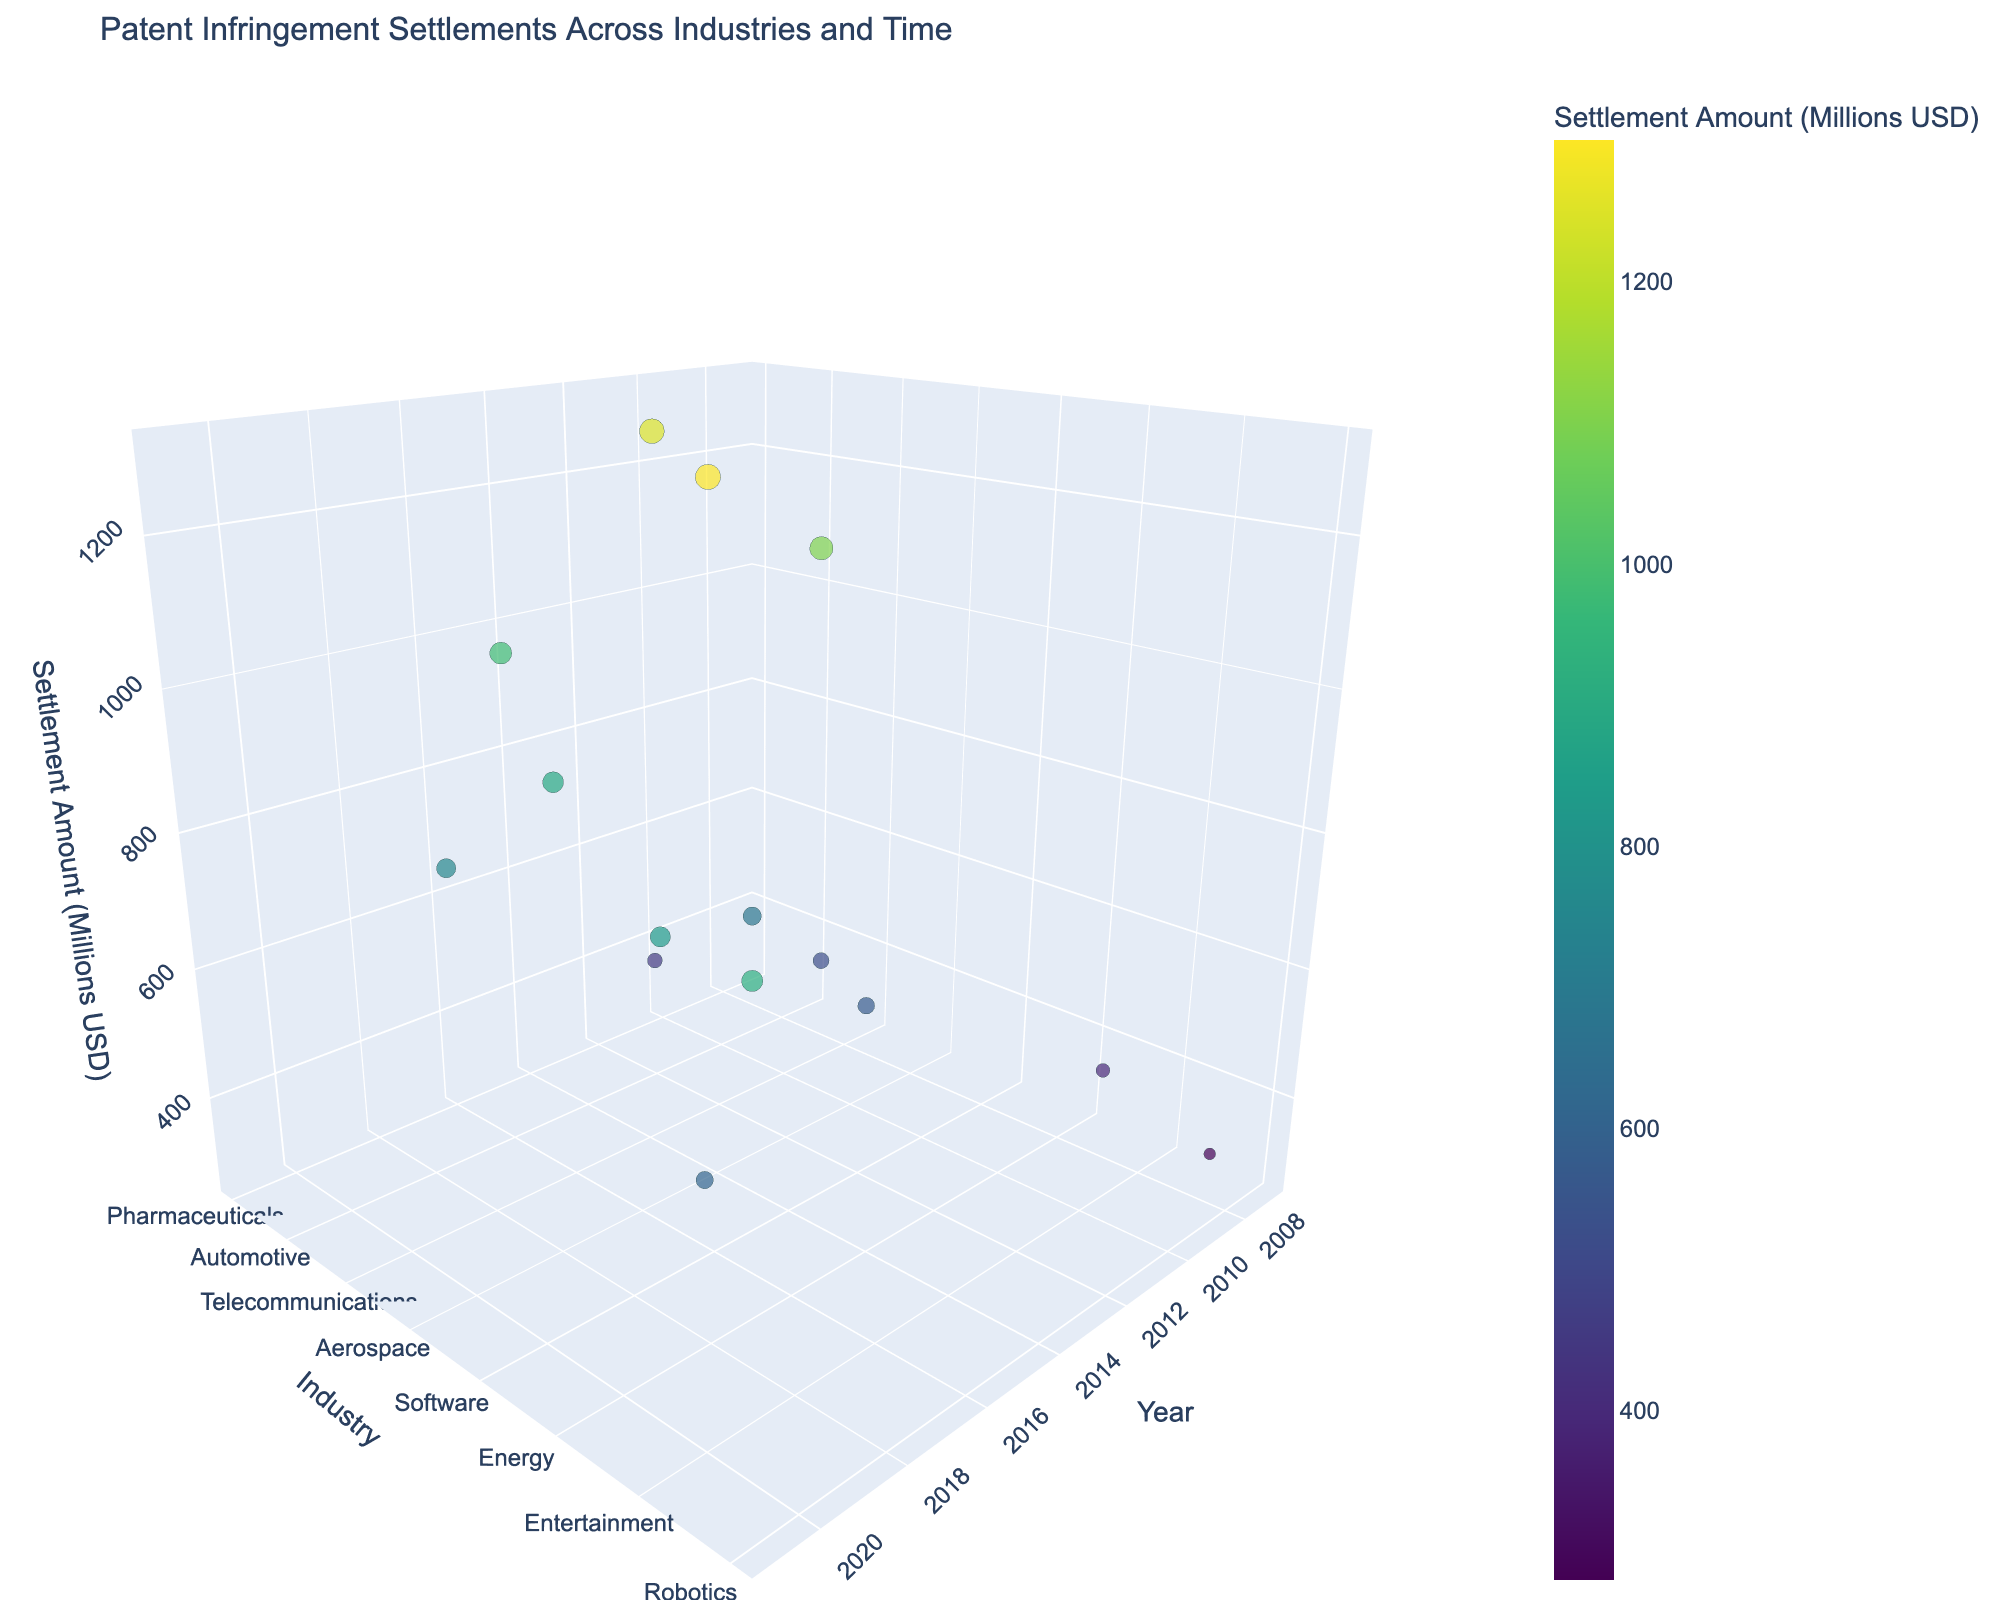What's the title of the figure? The title of the figure is usually found at the top of the chart, indicating the subject of the plot. Here, it shows the main focus of the data presented.
Answer: Patent Infringement Settlements Across Industries and Time What are the axes labels? The labels on the axes give information about what each axis represents. We have three axes to consider in this 3D plot: the x-axis, y-axis, and z-axis. Each label corresponds to the respective data being plotted.
Answer: Year, Industry, Settlement Amount (Millions USD) Which industry had the highest settlement amount, and what year was it settled? To find this answer, look at the maximum height (z-axis) on the scatter plot, and check the corresponding industry label (y-axis) and year (x-axis).
Answer: Software, 2016 How many data points are there in the figure? By counting the number of markers (data points) on the plot, we can determine the total number of unique observations. Each marker represents one patent settlement case.
Answer: 15 What's the difference in settlement amounts between the Pharmaceuticals industry in 2010 and the Technology industry in 2015? Locate both data points on the z-axis and calculate the difference. Pharmaceuticals 2010 has a settlement of 1250 million USD, and Technology 2015 has 980 million USD. The difference is 1250 - 980.
Answer: 270 million USD What is the median settlement amount across all industries? To find the median, list all the settlement amounts, sort them in ascending order, and find the middle value. If there is an even number of points, take the average of the two middle values.
Answer: 750 million USD Which industry had the earliest recorded settlement? Look along the x-axis for the earliest year and identify the corresponding industry on the y-axis. The earliest year here is 2007.
Answer: Agriculture Compare the settlement amounts between the Biotechnology industry in 2017 and the Energy industry in 2019. Which one is higher? Locate both data points on the z-axis and compare their heights. Biotechnology 2017 has 890 million USD, and Energy 2019 has 830 million USD. The higher amount is clear.
Answer: Biotechnology, 2017 Which year saw the highest settlement amount? Evaluate each data point by checking their z-axis positions to find the maximum value, then note the corresponding year on the x-axis.
Answer: 2016 What are the color and size representations for the data points? The color and size of the data points typically correspond to another dimension of the data. In this case, both elements represent the settlement amount, indicating both magnitude and category through visual markers.
Answer: Settlement Amount (Millions USD) 